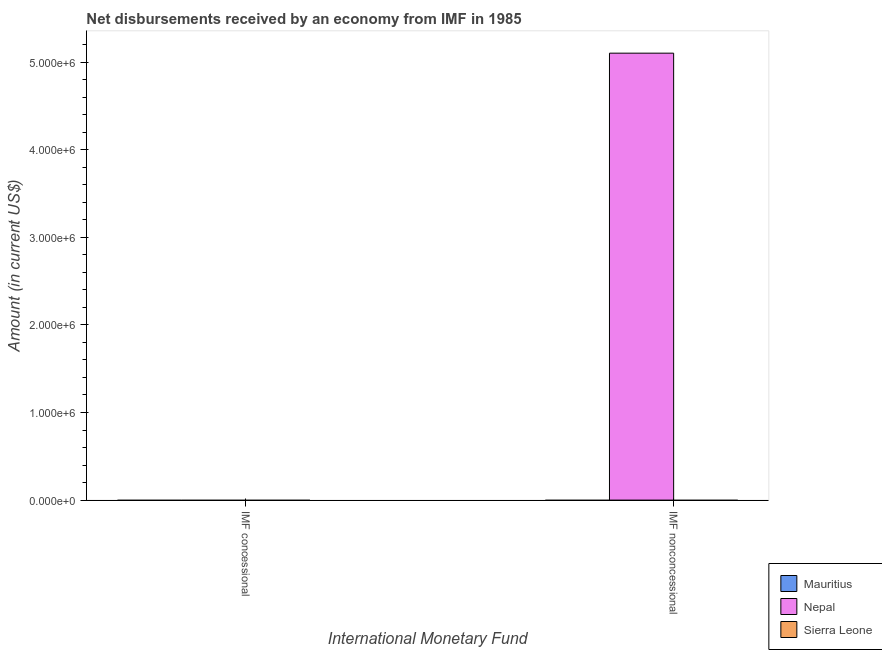How many different coloured bars are there?
Offer a terse response. 1. Are the number of bars on each tick of the X-axis equal?
Offer a very short reply. No. How many bars are there on the 1st tick from the left?
Your answer should be very brief. 0. What is the label of the 2nd group of bars from the left?
Your answer should be very brief. IMF nonconcessional. Across all countries, what is the maximum net non concessional disbursements from imf?
Your response must be concise. 5.10e+06. Across all countries, what is the minimum net non concessional disbursements from imf?
Keep it short and to the point. 0. In which country was the net non concessional disbursements from imf maximum?
Offer a terse response. Nepal. What is the total net non concessional disbursements from imf in the graph?
Keep it short and to the point. 5.10e+06. What is the average net non concessional disbursements from imf per country?
Give a very brief answer. 1.70e+06. In how many countries, is the net concessional disbursements from imf greater than the average net concessional disbursements from imf taken over all countries?
Offer a terse response. 0. Are all the bars in the graph horizontal?
Your response must be concise. No. Are the values on the major ticks of Y-axis written in scientific E-notation?
Give a very brief answer. Yes. How many legend labels are there?
Give a very brief answer. 3. How are the legend labels stacked?
Ensure brevity in your answer.  Vertical. What is the title of the graph?
Give a very brief answer. Net disbursements received by an economy from IMF in 1985. What is the label or title of the X-axis?
Provide a succinct answer. International Monetary Fund. What is the Amount (in current US$) in Mauritius in IMF concessional?
Provide a short and direct response. 0. What is the Amount (in current US$) of Nepal in IMF concessional?
Provide a short and direct response. 0. What is the Amount (in current US$) in Sierra Leone in IMF concessional?
Offer a very short reply. 0. What is the Amount (in current US$) in Mauritius in IMF nonconcessional?
Provide a short and direct response. 0. What is the Amount (in current US$) in Nepal in IMF nonconcessional?
Ensure brevity in your answer.  5.10e+06. Across all International Monetary Fund, what is the maximum Amount (in current US$) in Nepal?
Keep it short and to the point. 5.10e+06. Across all International Monetary Fund, what is the minimum Amount (in current US$) in Nepal?
Provide a short and direct response. 0. What is the total Amount (in current US$) in Nepal in the graph?
Your answer should be very brief. 5.10e+06. What is the total Amount (in current US$) of Sierra Leone in the graph?
Your response must be concise. 0. What is the average Amount (in current US$) of Nepal per International Monetary Fund?
Keep it short and to the point. 2.55e+06. What is the average Amount (in current US$) of Sierra Leone per International Monetary Fund?
Offer a very short reply. 0. What is the difference between the highest and the lowest Amount (in current US$) of Nepal?
Offer a very short reply. 5.10e+06. 